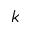Convert formula to latex. <formula><loc_0><loc_0><loc_500><loc_500>k</formula> 